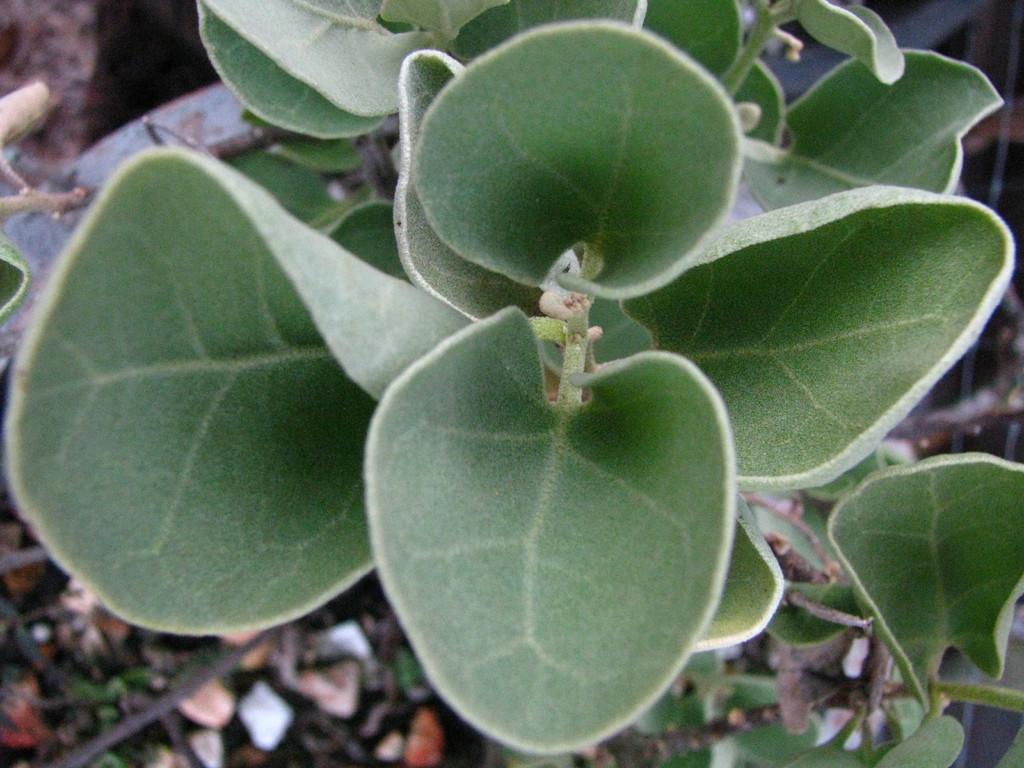Describe this image in one or two sentences. In this image we can see the leaves of a plant. At the bottom there are dry sticks and dry leaves. 